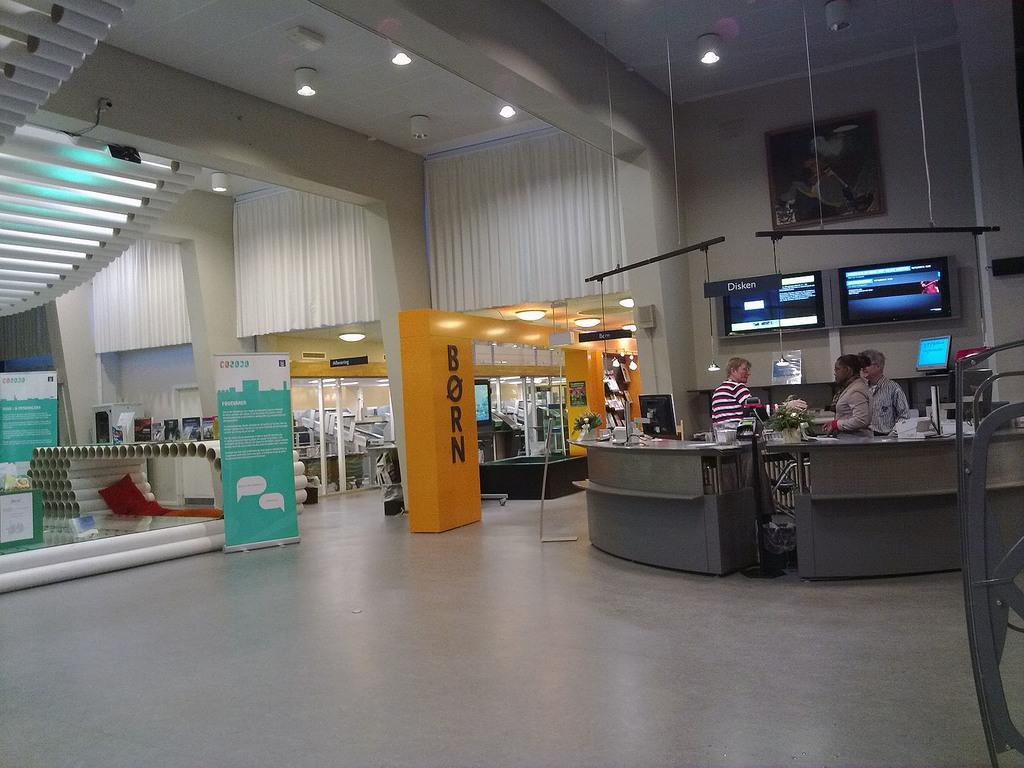In one or two sentences, can you explain what this image depicts? In this image I can see the floor, few banners, few white colored pipes, the desk, few persons standing, the wall, the ceiling, few lights to the ceiling, few screens, a monitor, a frame attached to the wall and few other objects in the background. 